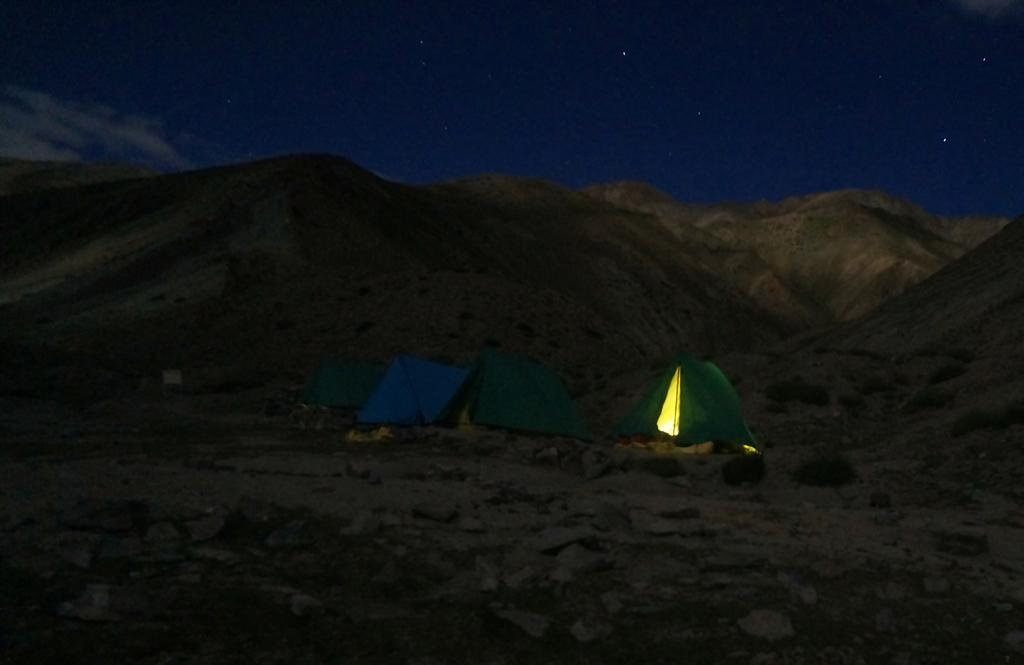What structures are present on the ground in the image? There are tents on the ground in the image. Can you describe the interior of one of the tents? There is a light inside one of the tents. What type of landscape can be seen in the background of the image? Mountains are visible in the background of the image. What else is visible in the background of the image? The sky is visible in the background of the image. Can you tell me how many forks are lying on the ground near the tents in the image? There are no forks present on the ground near the tents in the image. Is there a woman standing next to the tents in the image? There is no woman present in the image. 